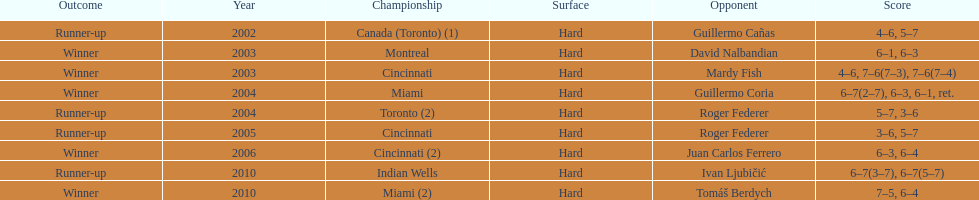How many total wins has he had? 5. 